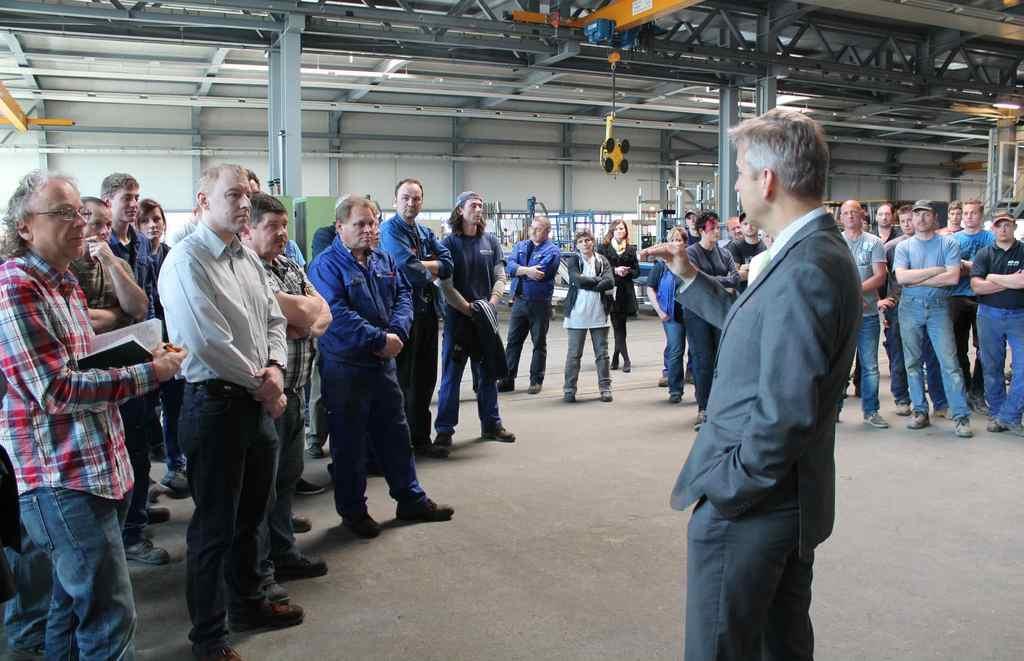How would you summarize this image in a sentence or two? In the image we can see there are people standing and there is a man standing and wearing formal suit. Behind there are mechanical machines. 